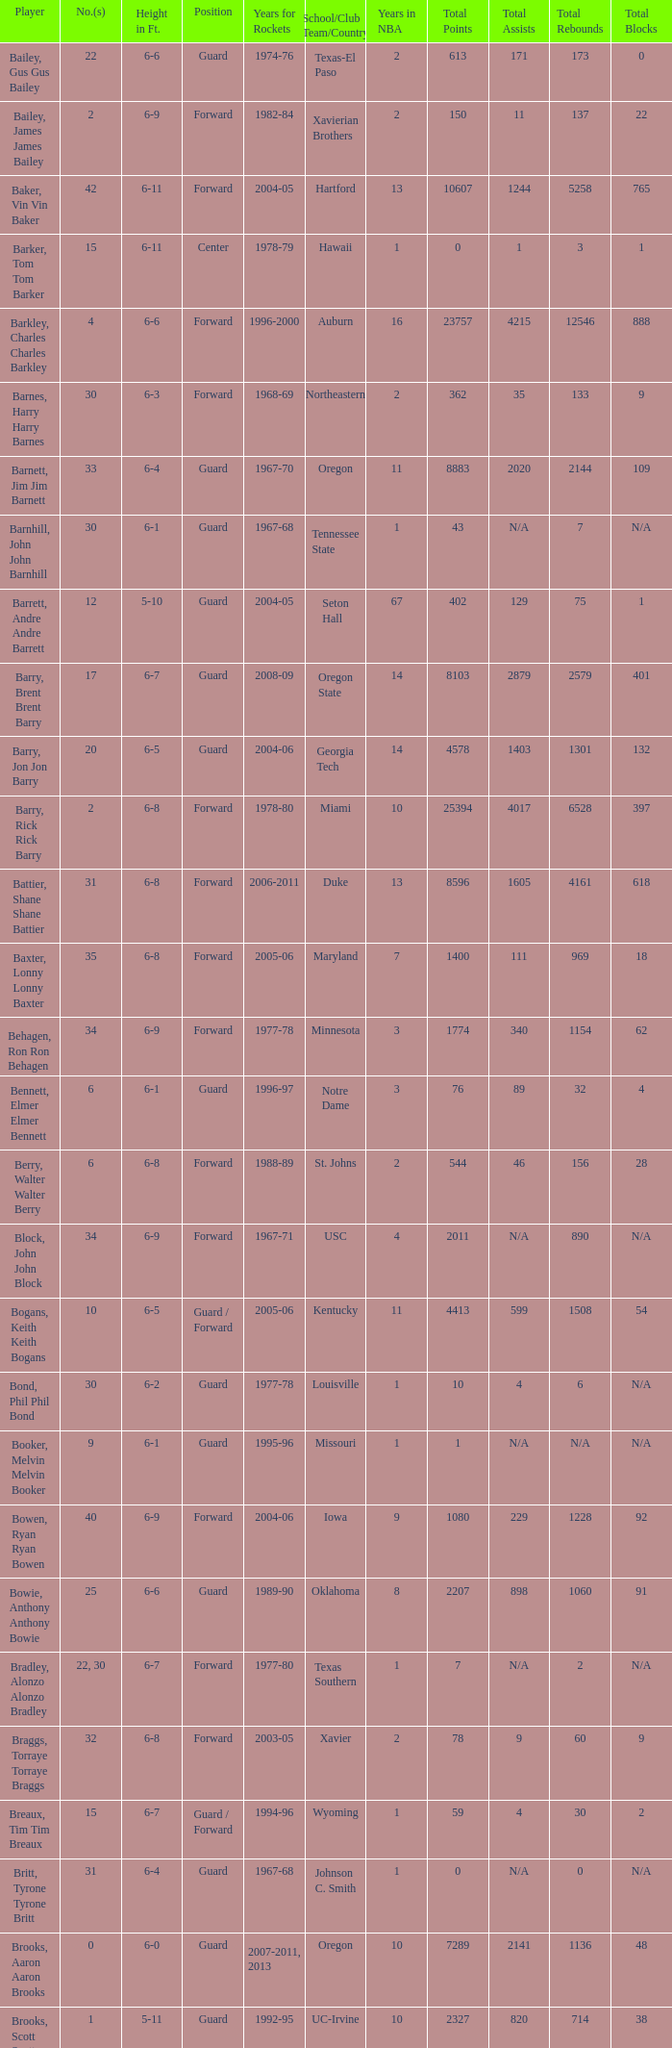What position is number 35 whose height is 6-6? Forward. 